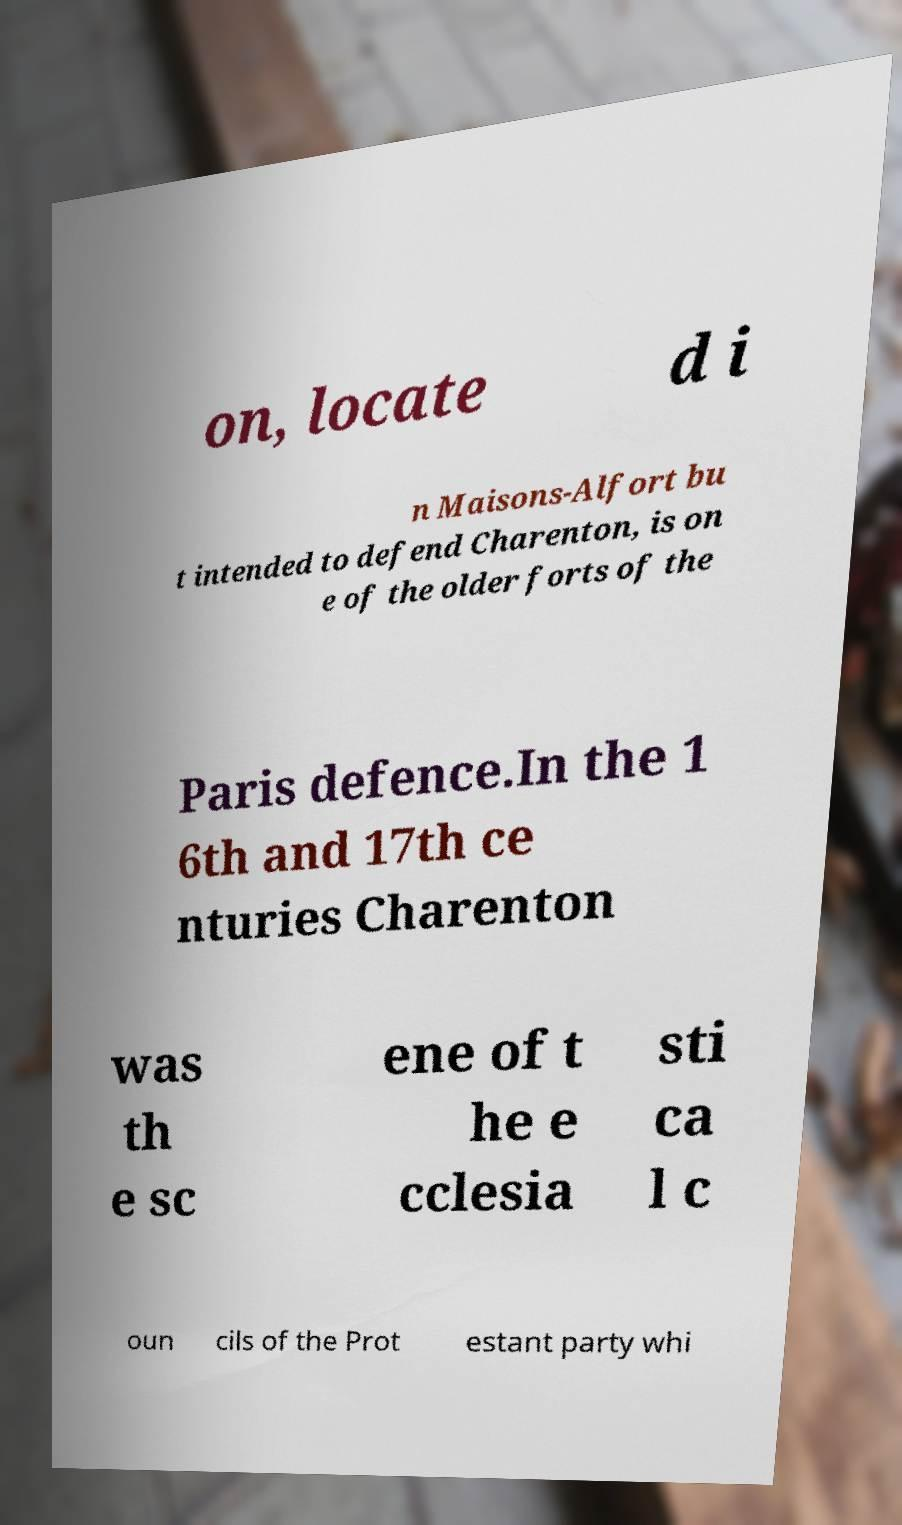Please identify and transcribe the text found in this image. on, locate d i n Maisons-Alfort bu t intended to defend Charenton, is on e of the older forts of the Paris defence.In the 1 6th and 17th ce nturies Charenton was th e sc ene of t he e cclesia sti ca l c oun cils of the Prot estant party whi 